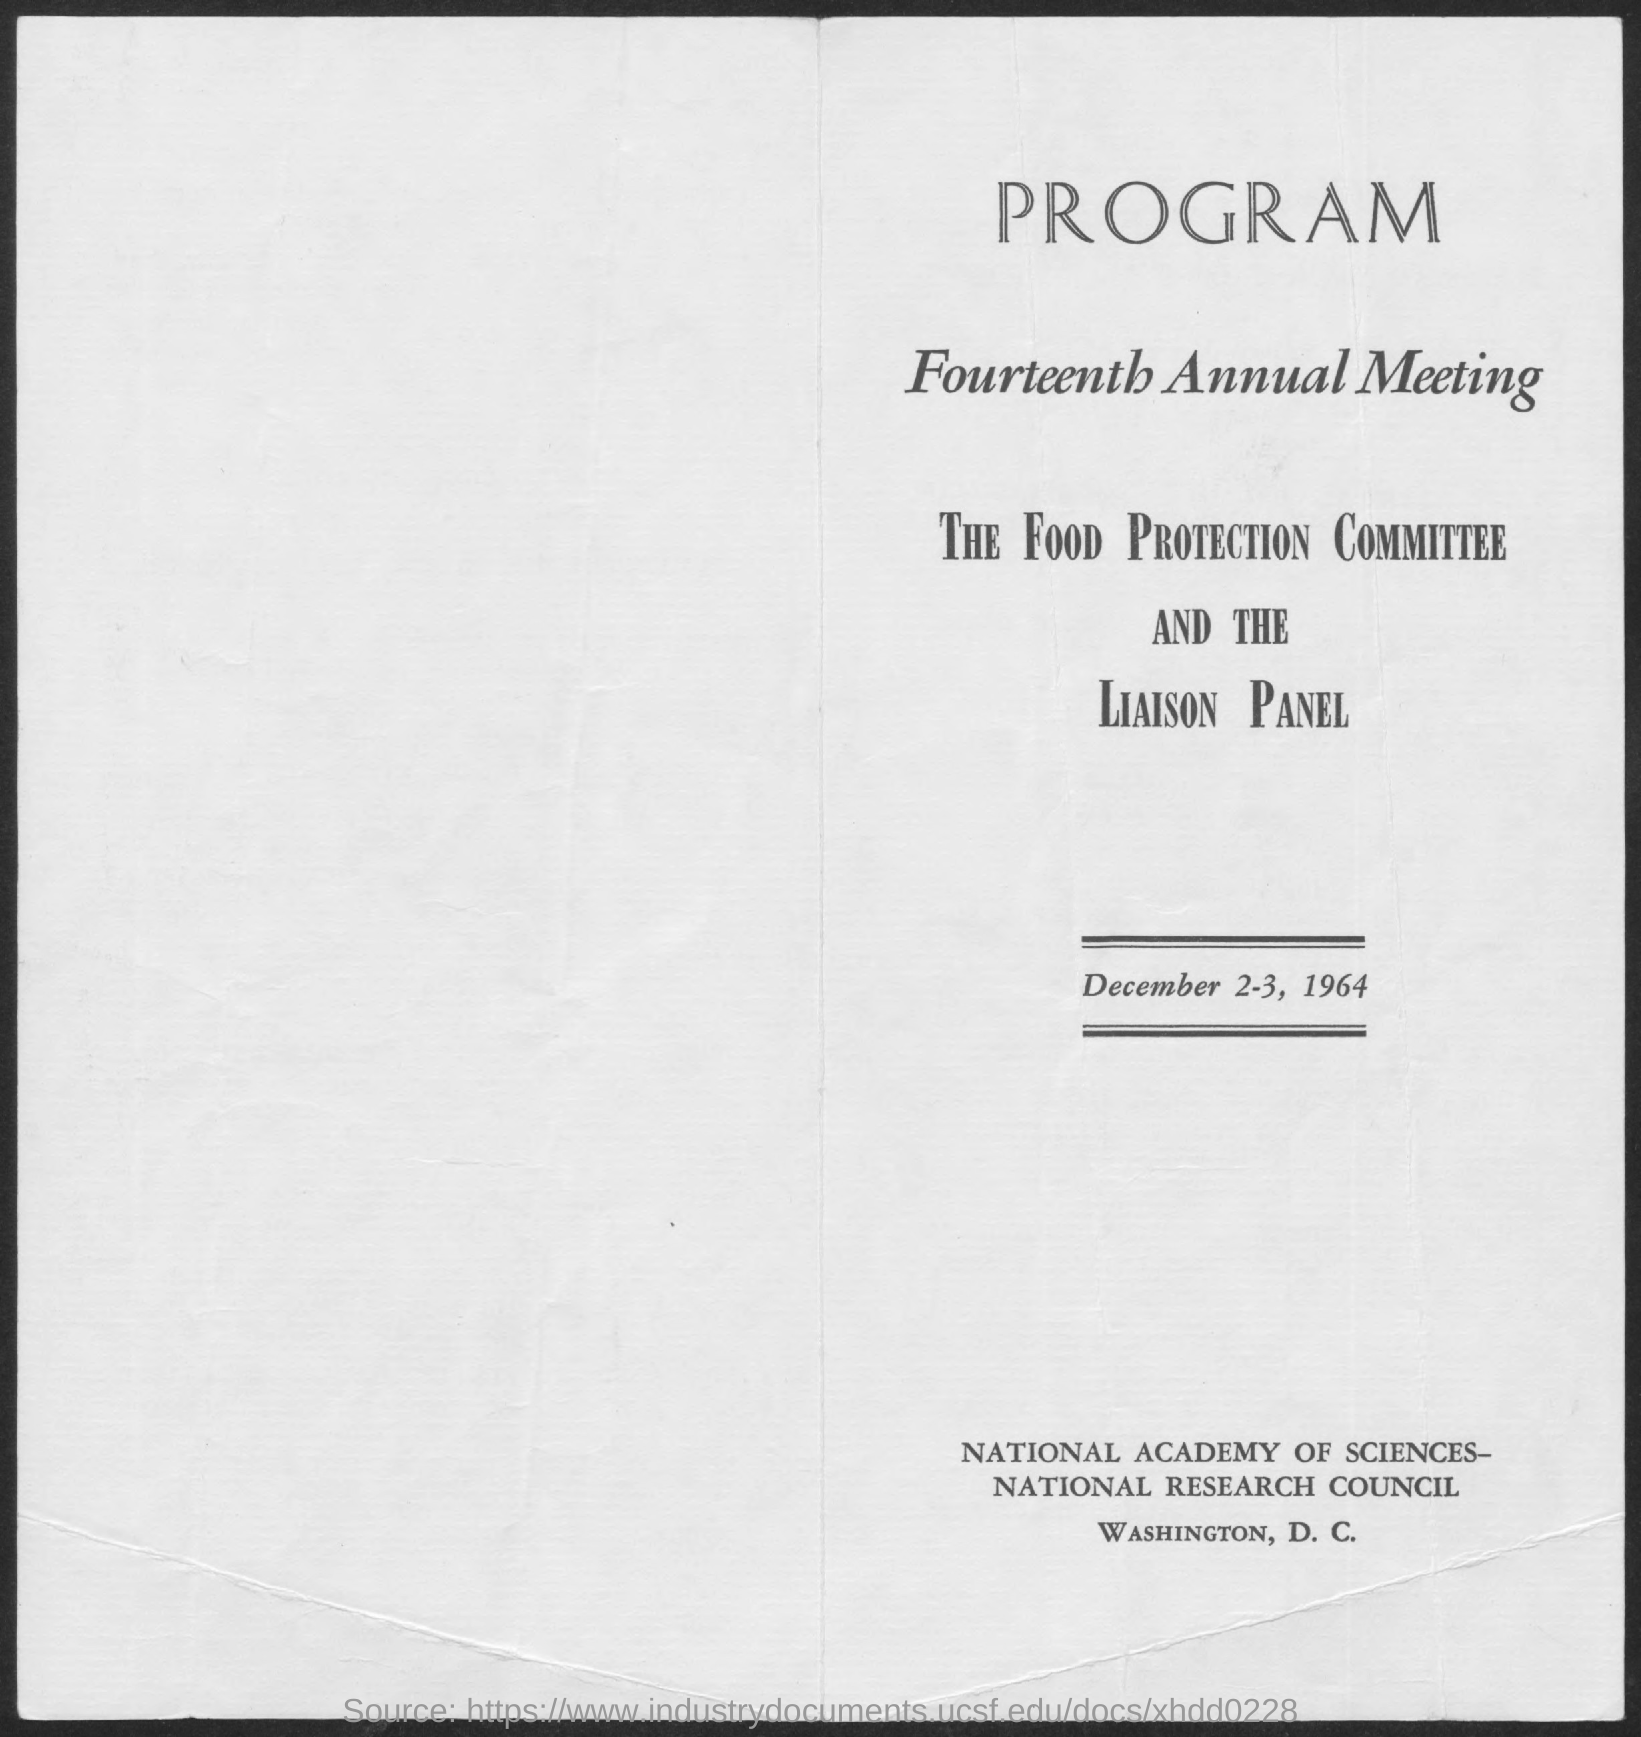What is the second title in this document?
Ensure brevity in your answer.  Fourteenth Annual Meeting. What is the date mentioned in the document?
Give a very brief answer. December 2-3, 1964. 